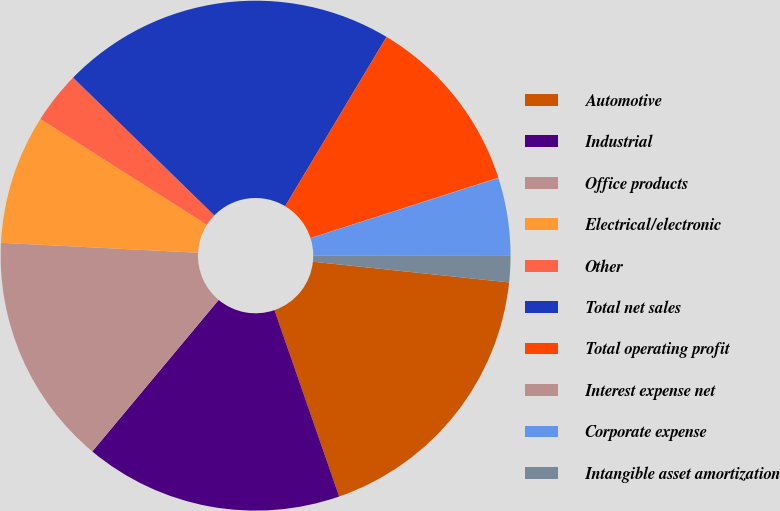Convert chart to OTSL. <chart><loc_0><loc_0><loc_500><loc_500><pie_chart><fcel>Automotive<fcel>Industrial<fcel>Office products<fcel>Electrical/electronic<fcel>Other<fcel>Total net sales<fcel>Total operating profit<fcel>Interest expense net<fcel>Corporate expense<fcel>Intangible asset amortization<nl><fcel>18.01%<fcel>16.38%<fcel>14.74%<fcel>8.2%<fcel>3.3%<fcel>21.28%<fcel>11.47%<fcel>0.03%<fcel>4.93%<fcel>1.66%<nl></chart> 